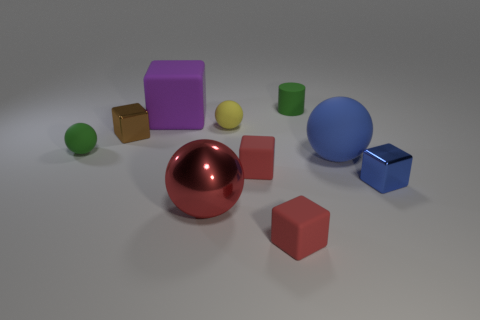Subtract all purple balls. How many red cubes are left? 2 Subtract all green spheres. How many spheres are left? 3 Subtract 1 blocks. How many blocks are left? 4 Subtract all small green matte spheres. How many spheres are left? 3 Subtract all gray blocks. Subtract all cyan cylinders. How many blocks are left? 5 Subtract all cylinders. How many objects are left? 9 Add 8 small brown metallic objects. How many small brown metallic objects are left? 9 Add 3 yellow matte objects. How many yellow matte objects exist? 4 Subtract 0 gray spheres. How many objects are left? 10 Subtract all blue shiny blocks. Subtract all big red metallic balls. How many objects are left? 8 